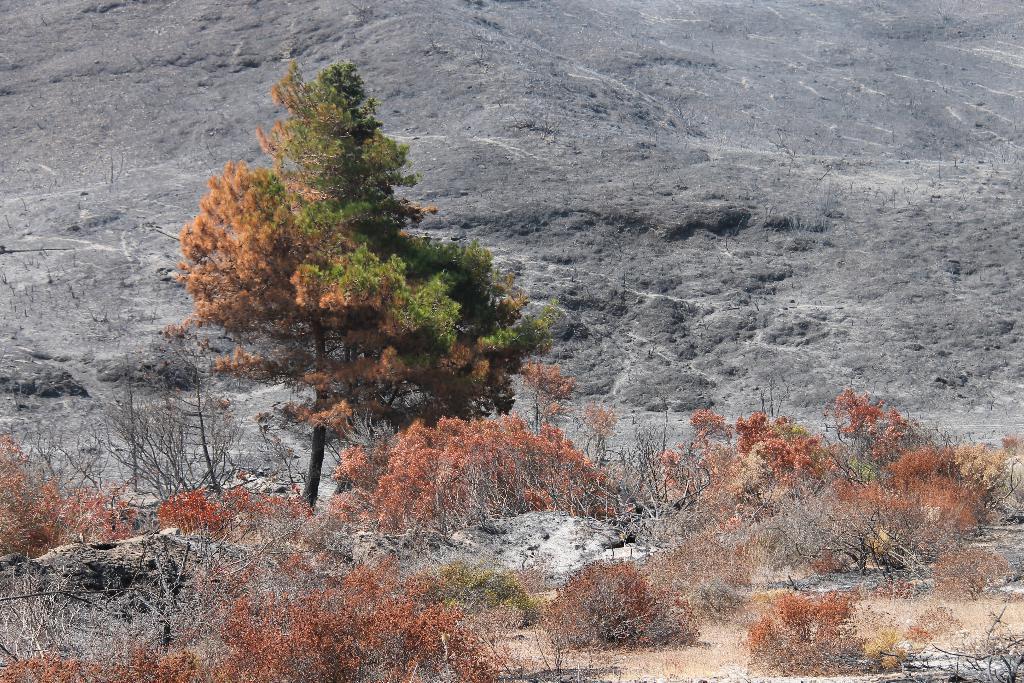Could you give a brief overview of what you see in this image? In this picture I can see bushes in the foreground. I can see trees. I can see the hill in the background. 